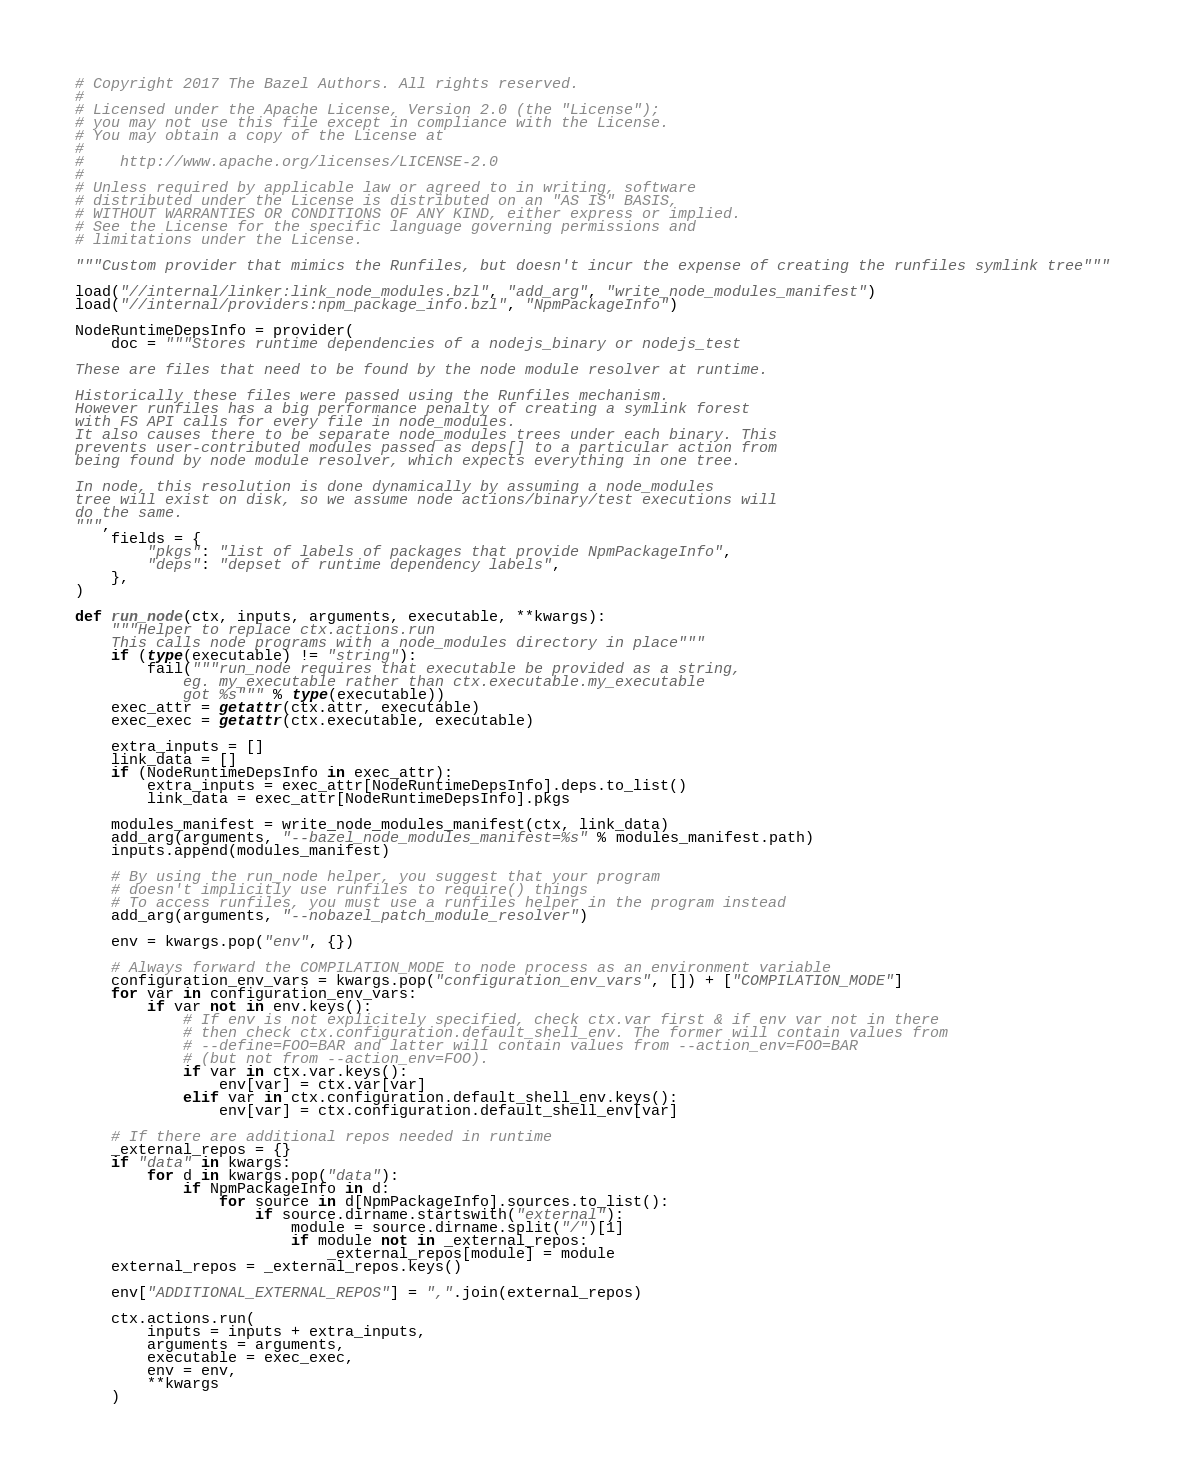Convert code to text. <code><loc_0><loc_0><loc_500><loc_500><_Python_># Copyright 2017 The Bazel Authors. All rights reserved.
#
# Licensed under the Apache License, Version 2.0 (the "License");
# you may not use this file except in compliance with the License.
# You may obtain a copy of the License at
#
#    http://www.apache.org/licenses/LICENSE-2.0
#
# Unless required by applicable law or agreed to in writing, software
# distributed under the License is distributed on an "AS IS" BASIS,
# WITHOUT WARRANTIES OR CONDITIONS OF ANY KIND, either express or implied.
# See the License for the specific language governing permissions and
# limitations under the License.

"""Custom provider that mimics the Runfiles, but doesn't incur the expense of creating the runfiles symlink tree"""

load("//internal/linker:link_node_modules.bzl", "add_arg", "write_node_modules_manifest")
load("//internal/providers:npm_package_info.bzl", "NpmPackageInfo")

NodeRuntimeDepsInfo = provider(
    doc = """Stores runtime dependencies of a nodejs_binary or nodejs_test

These are files that need to be found by the node module resolver at runtime.

Historically these files were passed using the Runfiles mechanism.
However runfiles has a big performance penalty of creating a symlink forest
with FS API calls for every file in node_modules.
It also causes there to be separate node_modules trees under each binary. This
prevents user-contributed modules passed as deps[] to a particular action from
being found by node module resolver, which expects everything in one tree.

In node, this resolution is done dynamically by assuming a node_modules
tree will exist on disk, so we assume node actions/binary/test executions will
do the same.
""",
    fields = {
        "pkgs": "list of labels of packages that provide NpmPackageInfo",
        "deps": "depset of runtime dependency labels",
    },
)

def run_node(ctx, inputs, arguments, executable, **kwargs):
    """Helper to replace ctx.actions.run
    This calls node programs with a node_modules directory in place"""
    if (type(executable) != "string"):
        fail("""run_node requires that executable be provided as a string,
            eg. my_executable rather than ctx.executable.my_executable
            got %s""" % type(executable))
    exec_attr = getattr(ctx.attr, executable)
    exec_exec = getattr(ctx.executable, executable)

    extra_inputs = []
    link_data = []
    if (NodeRuntimeDepsInfo in exec_attr):
        extra_inputs = exec_attr[NodeRuntimeDepsInfo].deps.to_list()
        link_data = exec_attr[NodeRuntimeDepsInfo].pkgs

    modules_manifest = write_node_modules_manifest(ctx, link_data)
    add_arg(arguments, "--bazel_node_modules_manifest=%s" % modules_manifest.path)
    inputs.append(modules_manifest)

    # By using the run_node helper, you suggest that your program
    # doesn't implicitly use runfiles to require() things
    # To access runfiles, you must use a runfiles helper in the program instead
    add_arg(arguments, "--nobazel_patch_module_resolver")

    env = kwargs.pop("env", {})

    # Always forward the COMPILATION_MODE to node process as an environment variable
    configuration_env_vars = kwargs.pop("configuration_env_vars", []) + ["COMPILATION_MODE"]
    for var in configuration_env_vars:
        if var not in env.keys():
            # If env is not explicitely specified, check ctx.var first & if env var not in there
            # then check ctx.configuration.default_shell_env. The former will contain values from
            # --define=FOO=BAR and latter will contain values from --action_env=FOO=BAR
            # (but not from --action_env=FOO).
            if var in ctx.var.keys():
                env[var] = ctx.var[var]
            elif var in ctx.configuration.default_shell_env.keys():
                env[var] = ctx.configuration.default_shell_env[var]

    # If there are additional repos needed in runtime
    _external_repos = {}
    if "data" in kwargs:
        for d in kwargs.pop("data"):
            if NpmPackageInfo in d:
                for source in d[NpmPackageInfo].sources.to_list():
                    if source.dirname.startswith("external"):
                        module = source.dirname.split("/")[1]
                        if module not in _external_repos:
                            _external_repos[module] = module
    external_repos = _external_repos.keys()

    env["ADDITIONAL_EXTERNAL_REPOS"] = ",".join(external_repos)

    ctx.actions.run(
        inputs = inputs + extra_inputs,
        arguments = arguments,
        executable = exec_exec,
        env = env,
        **kwargs
    )
</code> 